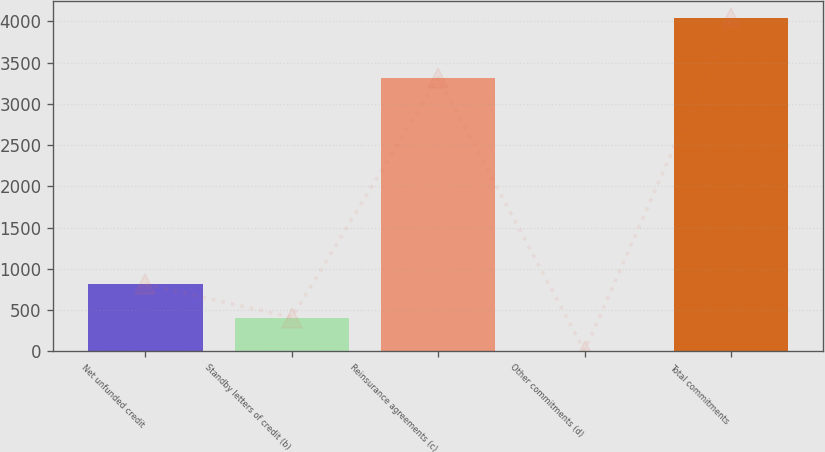Convert chart. <chart><loc_0><loc_0><loc_500><loc_500><bar_chart><fcel>Net unfunded credit<fcel>Standby letters of credit (b)<fcel>Reinsurance agreements (c)<fcel>Other commitments (d)<fcel>Total commitments<nl><fcel>812.2<fcel>408.1<fcel>3318<fcel>4<fcel>4045<nl></chart> 